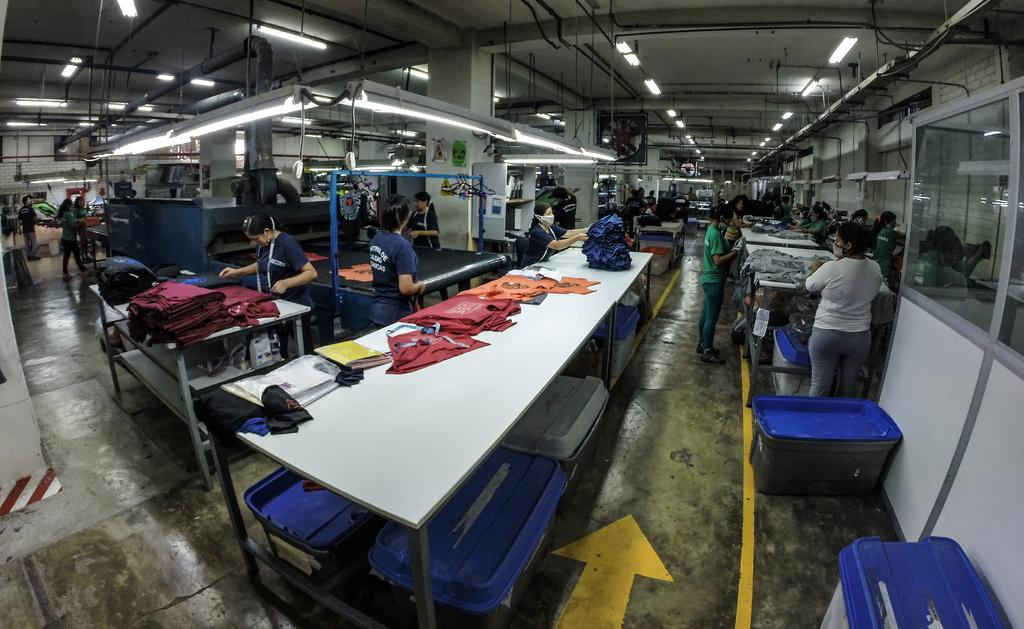What is located at the top of the image? There are lights at the top of the image. What can be seen in the middle of the image? There are tables in the middle of the image. What is on the tables? There are clothes on the tables. Who is near the tables? There are people near the tables. What are the people doing? The people are stretching something. How many rabbits are sitting on the tables in the image? There are no rabbits present in the image; it features tables with clothes and people stretching something. What type of paper is being used by the people in the image? There is no paper visible in the image; the people are stretching something, which is likely not paper. 